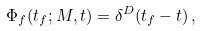Convert formula to latex. <formula><loc_0><loc_0><loc_500><loc_500>\Phi _ { f } ( t _ { f } ; M , t ) = \delta ^ { D } ( t _ { f } - t ) \, ,</formula> 